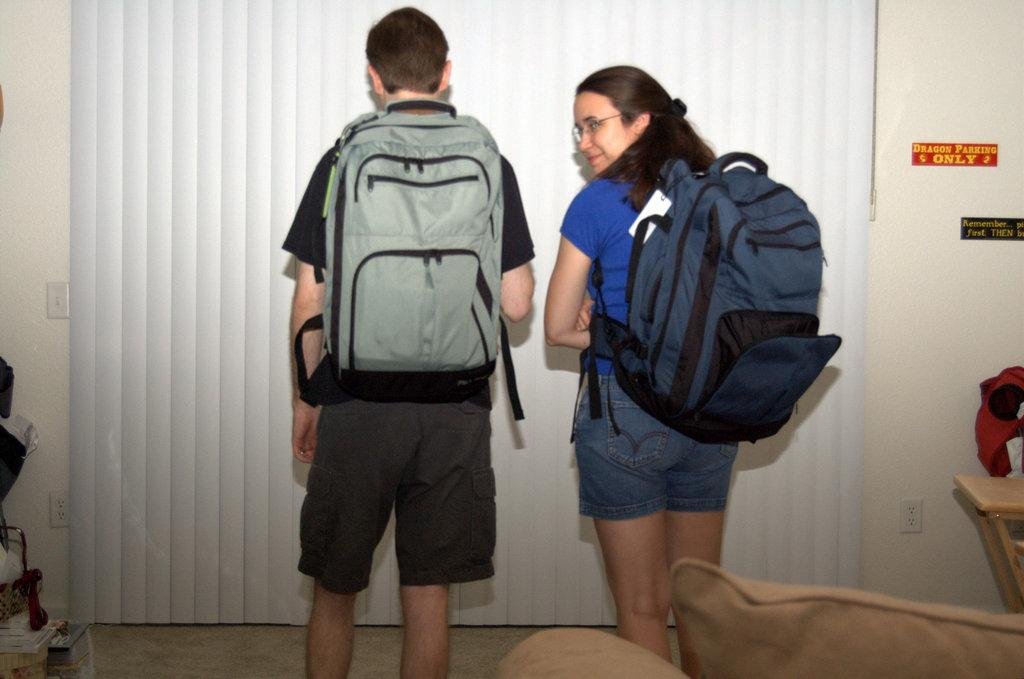<image>
Share a concise interpretation of the image provided. Two people stand next to a plaque reading Dragon Parking Only. 